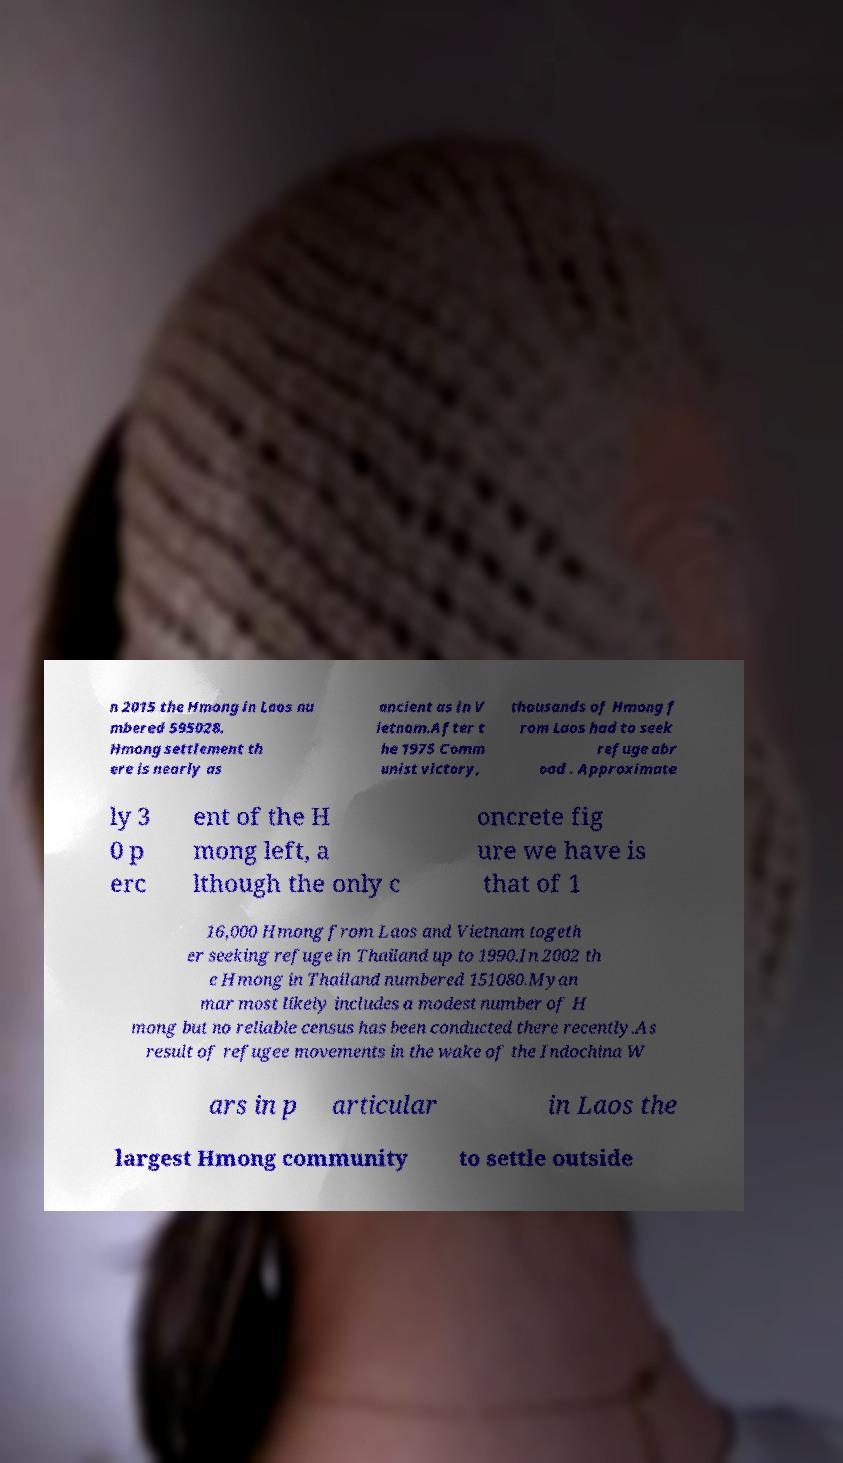For documentation purposes, I need the text within this image transcribed. Could you provide that? n 2015 the Hmong in Laos nu mbered 595028. Hmong settlement th ere is nearly as ancient as in V ietnam.After t he 1975 Comm unist victory, thousands of Hmong f rom Laos had to seek refuge abr oad . Approximate ly 3 0 p erc ent of the H mong left, a lthough the only c oncrete fig ure we have is that of 1 16,000 Hmong from Laos and Vietnam togeth er seeking refuge in Thailand up to 1990.In 2002 th e Hmong in Thailand numbered 151080.Myan mar most likely includes a modest number of H mong but no reliable census has been conducted there recently.As result of refugee movements in the wake of the Indochina W ars in p articular in Laos the largest Hmong community to settle outside 